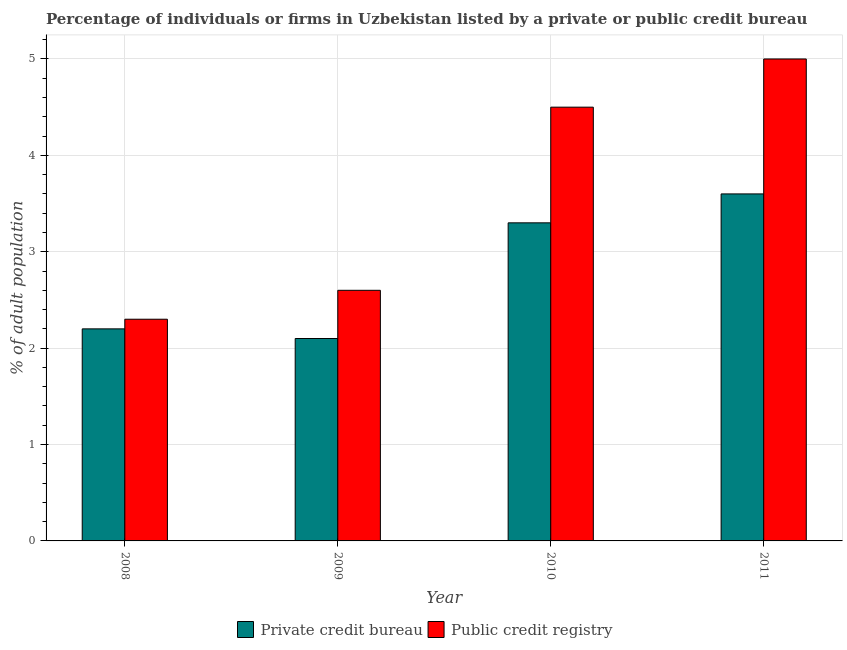Are the number of bars on each tick of the X-axis equal?
Provide a succinct answer. Yes. How many bars are there on the 3rd tick from the left?
Provide a short and direct response. 2. How many bars are there on the 4th tick from the right?
Make the answer very short. 2. What is the label of the 1st group of bars from the left?
Provide a succinct answer. 2008. What is the percentage of firms listed by private credit bureau in 2009?
Your answer should be compact. 2.1. Across all years, what is the maximum percentage of firms listed by private credit bureau?
Provide a short and direct response. 3.6. Across all years, what is the minimum percentage of firms listed by private credit bureau?
Provide a succinct answer. 2.1. What is the difference between the percentage of firms listed by private credit bureau in 2009 and that in 2010?
Offer a very short reply. -1.2. What is the difference between the percentage of firms listed by private credit bureau in 2011 and the percentage of firms listed by public credit bureau in 2008?
Make the answer very short. 1.4. What is the average percentage of firms listed by public credit bureau per year?
Your answer should be compact. 3.6. In how many years, is the percentage of firms listed by public credit bureau greater than 0.2 %?
Offer a terse response. 4. What is the ratio of the percentage of firms listed by private credit bureau in 2008 to that in 2009?
Offer a very short reply. 1.05. Is the percentage of firms listed by public credit bureau in 2008 less than that in 2009?
Give a very brief answer. Yes. What is the difference between the highest and the second highest percentage of firms listed by private credit bureau?
Ensure brevity in your answer.  0.3. What is the difference between the highest and the lowest percentage of firms listed by private credit bureau?
Make the answer very short. 1.5. In how many years, is the percentage of firms listed by private credit bureau greater than the average percentage of firms listed by private credit bureau taken over all years?
Provide a short and direct response. 2. What does the 2nd bar from the left in 2008 represents?
Offer a terse response. Public credit registry. What does the 1st bar from the right in 2011 represents?
Offer a very short reply. Public credit registry. Does the graph contain any zero values?
Your answer should be very brief. No. Does the graph contain grids?
Your answer should be compact. Yes. Where does the legend appear in the graph?
Your response must be concise. Bottom center. How are the legend labels stacked?
Provide a succinct answer. Horizontal. What is the title of the graph?
Make the answer very short. Percentage of individuals or firms in Uzbekistan listed by a private or public credit bureau. Does "Revenue" appear as one of the legend labels in the graph?
Your answer should be very brief. No. What is the label or title of the Y-axis?
Your answer should be very brief. % of adult population. What is the % of adult population in Private credit bureau in 2008?
Offer a terse response. 2.2. What is the % of adult population in Public credit registry in 2010?
Your response must be concise. 4.5. What is the % of adult population of Private credit bureau in 2011?
Make the answer very short. 3.6. What is the % of adult population in Public credit registry in 2011?
Give a very brief answer. 5. Across all years, what is the maximum % of adult population in Private credit bureau?
Offer a very short reply. 3.6. Across all years, what is the minimum % of adult population in Public credit registry?
Make the answer very short. 2.3. What is the total % of adult population of Private credit bureau in the graph?
Ensure brevity in your answer.  11.2. What is the difference between the % of adult population in Private credit bureau in 2008 and that in 2009?
Ensure brevity in your answer.  0.1. What is the difference between the % of adult population of Public credit registry in 2008 and that in 2009?
Make the answer very short. -0.3. What is the difference between the % of adult population of Private credit bureau in 2008 and that in 2010?
Make the answer very short. -1.1. What is the difference between the % of adult population in Public credit registry in 2008 and that in 2010?
Keep it short and to the point. -2.2. What is the difference between the % of adult population in Public credit registry in 2008 and that in 2011?
Give a very brief answer. -2.7. What is the difference between the % of adult population of Public credit registry in 2009 and that in 2010?
Make the answer very short. -1.9. What is the difference between the % of adult population of Private credit bureau in 2009 and that in 2011?
Offer a terse response. -1.5. What is the difference between the % of adult population in Private credit bureau in 2010 and that in 2011?
Give a very brief answer. -0.3. What is the difference between the % of adult population of Public credit registry in 2010 and that in 2011?
Provide a short and direct response. -0.5. What is the difference between the % of adult population of Private credit bureau in 2008 and the % of adult population of Public credit registry in 2009?
Offer a terse response. -0.4. What is the difference between the % of adult population in Private credit bureau in 2008 and the % of adult population in Public credit registry in 2010?
Offer a terse response. -2.3. What is the difference between the % of adult population in Private credit bureau in 2008 and the % of adult population in Public credit registry in 2011?
Your answer should be compact. -2.8. What is the difference between the % of adult population of Private credit bureau in 2009 and the % of adult population of Public credit registry in 2011?
Provide a short and direct response. -2.9. In the year 2008, what is the difference between the % of adult population of Private credit bureau and % of adult population of Public credit registry?
Your answer should be compact. -0.1. In the year 2010, what is the difference between the % of adult population in Private credit bureau and % of adult population in Public credit registry?
Your response must be concise. -1.2. In the year 2011, what is the difference between the % of adult population in Private credit bureau and % of adult population in Public credit registry?
Give a very brief answer. -1.4. What is the ratio of the % of adult population of Private credit bureau in 2008 to that in 2009?
Offer a terse response. 1.05. What is the ratio of the % of adult population in Public credit registry in 2008 to that in 2009?
Offer a terse response. 0.88. What is the ratio of the % of adult population of Public credit registry in 2008 to that in 2010?
Give a very brief answer. 0.51. What is the ratio of the % of adult population in Private credit bureau in 2008 to that in 2011?
Your answer should be compact. 0.61. What is the ratio of the % of adult population in Public credit registry in 2008 to that in 2011?
Provide a succinct answer. 0.46. What is the ratio of the % of adult population of Private credit bureau in 2009 to that in 2010?
Your answer should be compact. 0.64. What is the ratio of the % of adult population of Public credit registry in 2009 to that in 2010?
Make the answer very short. 0.58. What is the ratio of the % of adult population in Private credit bureau in 2009 to that in 2011?
Provide a short and direct response. 0.58. What is the ratio of the % of adult population of Public credit registry in 2009 to that in 2011?
Your answer should be very brief. 0.52. What is the ratio of the % of adult population in Public credit registry in 2010 to that in 2011?
Give a very brief answer. 0.9. What is the difference between the highest and the second highest % of adult population in Private credit bureau?
Ensure brevity in your answer.  0.3. 